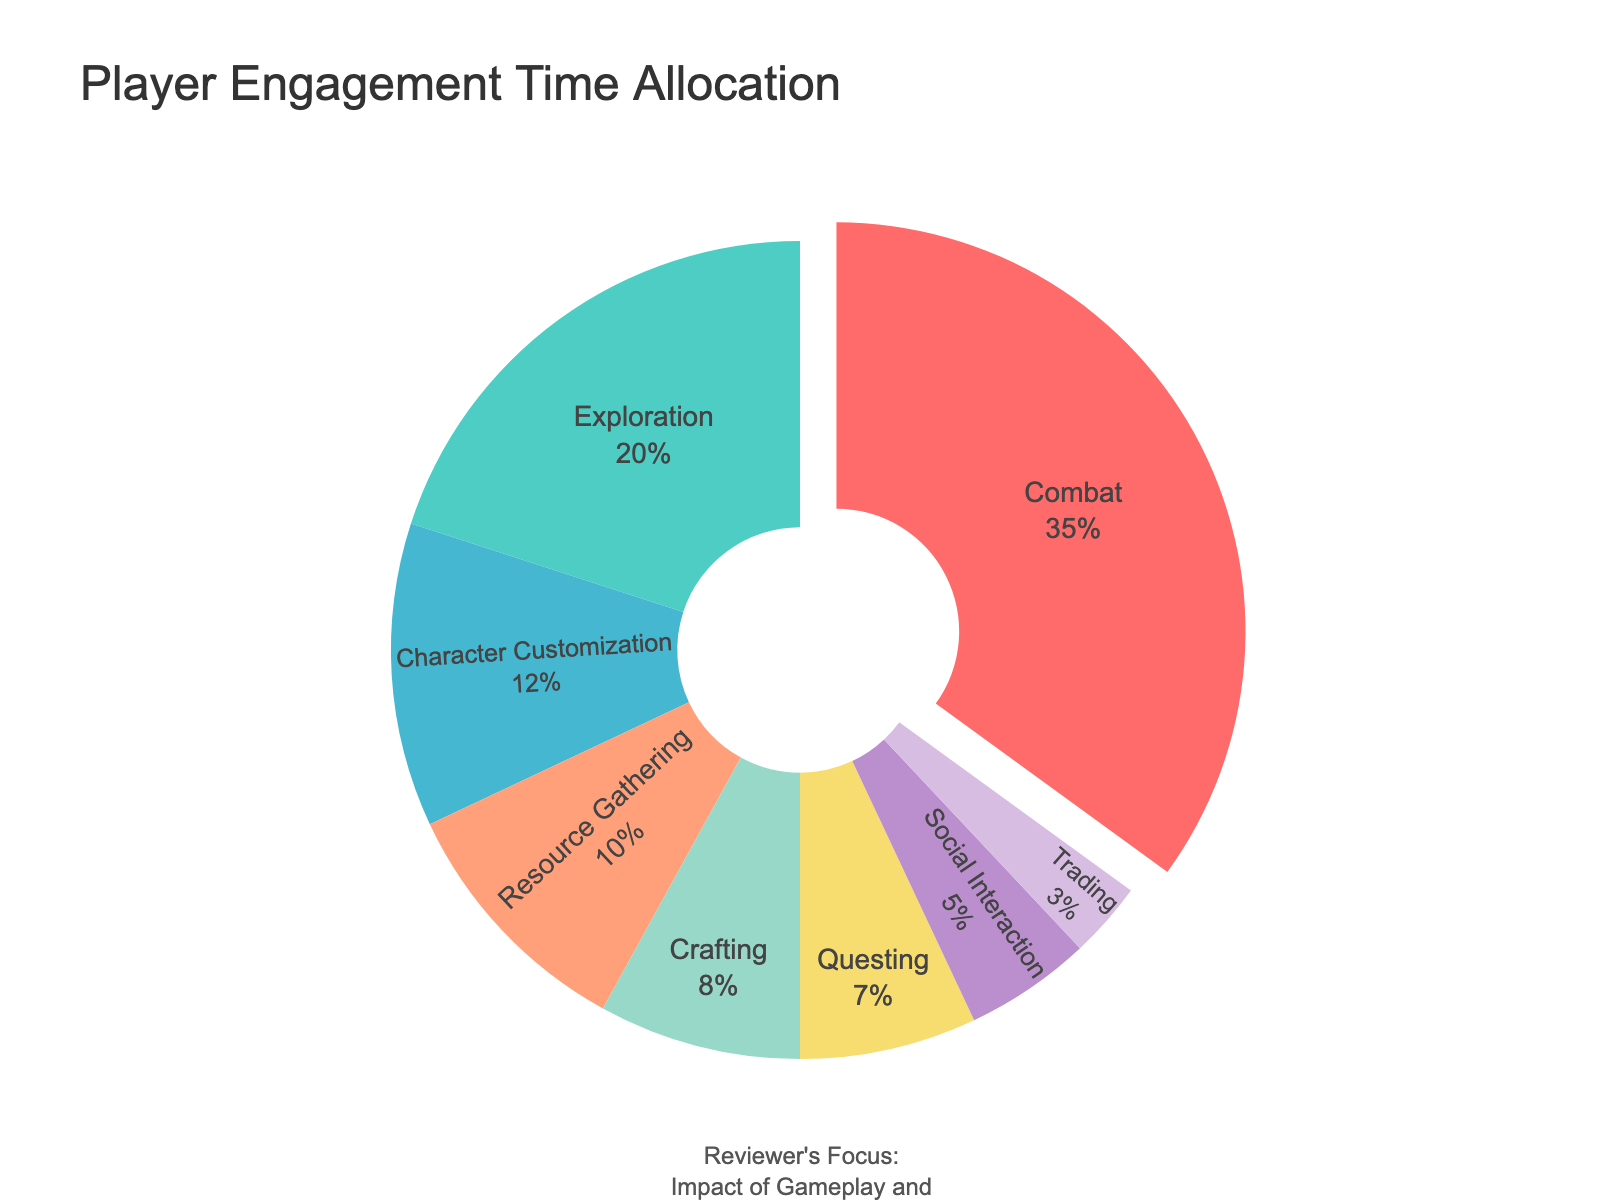What's the most common in-game activity based on the time allocation? Look for the activity with the highest percentage allocation in the pie chart. Combat has the largest slice, listed as 35%.
Answer: Combat What is the combined time allocation for Character Customization and Crafting? Identify the percentages for Character Customization (12%) and Crafting (8%). Add these two values together: 12% + 8% = 20%.
Answer: 20% Which activity has the smallest time allocation, and how much is it? Find the smallest slice in the pie chart, which visually appears the smallest. The activity is Trading with a 3% time allocation.
Answer: Trading, 3% How does the time allocation for Social Interaction compare to that of Resource Gathering? Compare the percentages for Social Interaction (5%) and Resource Gathering (10%). Social Interaction's allocation is less than Resource Gathering by 5%.
Answer: Social Interaction is 5% less What percentage of time is allocated to activities other than Combat and Exploration? Calculate the total allocation excluding Combat (35%) and Exploration (20%). Subtract these from 100%: 100% - 35% - 20% = 45%.
Answer: 45% What is the sum of time allocated to Combat, Exploration, and Questing? Sum the allocations of Combat (35%), Exploration (20%), and Questing (7%): 35% + 20% + 7% = 62%.
Answer: 62% What percentage of time is allocated to Combat relative to Social Interaction and Trading combined? Find the percentages for Social Interaction (5%) and Trading (3%). Their combined total is 5% + 3% = 8%. Then, compare it to Combat (35%): 35% / 8% = 4.375 or 437.5%.
Answer: 437.5% Which activity category uses a green color and what is its associated time allocation? The pie chart uses a green color for Exploration. The associated allocation is seen in the legend next to Exploration as 20%.
Answer: Exploration, 20% 